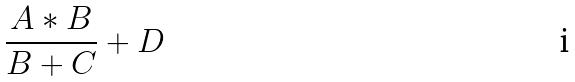Convert formula to latex. <formula><loc_0><loc_0><loc_500><loc_500>\frac { A * B } { B + C } + D</formula> 